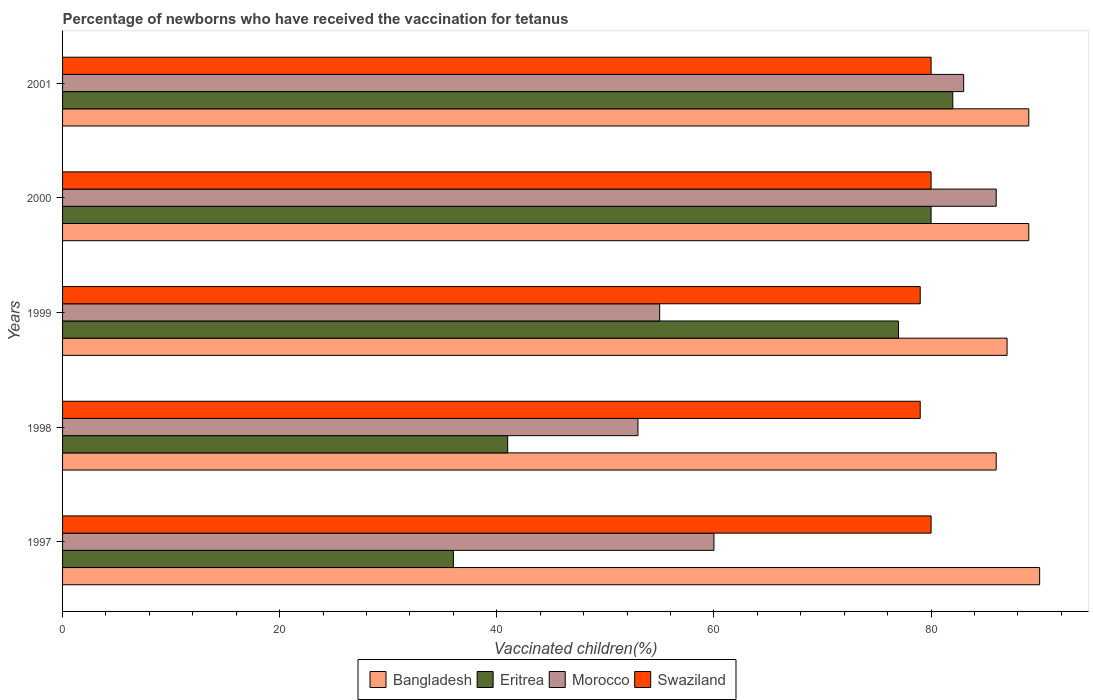Are the number of bars on each tick of the Y-axis equal?
Your answer should be very brief. Yes. How many bars are there on the 2nd tick from the bottom?
Your answer should be very brief. 4. What is the percentage of vaccinated children in Bangladesh in 1999?
Ensure brevity in your answer.  87. In which year was the percentage of vaccinated children in Swaziland maximum?
Your answer should be very brief. 1997. In which year was the percentage of vaccinated children in Eritrea minimum?
Keep it short and to the point. 1997. What is the total percentage of vaccinated children in Bangladesh in the graph?
Your answer should be compact. 441. What is the difference between the percentage of vaccinated children in Eritrea in 1999 and that in 2001?
Give a very brief answer. -5. What is the difference between the percentage of vaccinated children in Eritrea in 1997 and the percentage of vaccinated children in Morocco in 2001?
Give a very brief answer. -47. What is the average percentage of vaccinated children in Swaziland per year?
Your response must be concise. 79.6. What is the ratio of the percentage of vaccinated children in Swaziland in 1997 to that in 1999?
Ensure brevity in your answer.  1.01. In how many years, is the percentage of vaccinated children in Eritrea greater than the average percentage of vaccinated children in Eritrea taken over all years?
Ensure brevity in your answer.  3. Is the sum of the percentage of vaccinated children in Morocco in 1999 and 2000 greater than the maximum percentage of vaccinated children in Bangladesh across all years?
Give a very brief answer. Yes. What does the 3rd bar from the top in 1998 represents?
Keep it short and to the point. Eritrea. What does the 1st bar from the bottom in 2000 represents?
Provide a short and direct response. Bangladesh. Is it the case that in every year, the sum of the percentage of vaccinated children in Eritrea and percentage of vaccinated children in Bangladesh is greater than the percentage of vaccinated children in Swaziland?
Offer a very short reply. Yes. What is the difference between two consecutive major ticks on the X-axis?
Make the answer very short. 20. Does the graph contain any zero values?
Make the answer very short. No. Does the graph contain grids?
Keep it short and to the point. No. What is the title of the graph?
Keep it short and to the point. Percentage of newborns who have received the vaccination for tetanus. Does "Senegal" appear as one of the legend labels in the graph?
Keep it short and to the point. No. What is the label or title of the X-axis?
Give a very brief answer. Vaccinated children(%). What is the Vaccinated children(%) of Eritrea in 1997?
Make the answer very short. 36. What is the Vaccinated children(%) in Swaziland in 1997?
Keep it short and to the point. 80. What is the Vaccinated children(%) in Swaziland in 1998?
Offer a terse response. 79. What is the Vaccinated children(%) of Bangladesh in 1999?
Ensure brevity in your answer.  87. What is the Vaccinated children(%) in Eritrea in 1999?
Provide a short and direct response. 77. What is the Vaccinated children(%) of Morocco in 1999?
Your answer should be very brief. 55. What is the Vaccinated children(%) in Swaziland in 1999?
Make the answer very short. 79. What is the Vaccinated children(%) in Bangladesh in 2000?
Provide a succinct answer. 89. What is the Vaccinated children(%) in Eritrea in 2000?
Your answer should be compact. 80. What is the Vaccinated children(%) in Bangladesh in 2001?
Give a very brief answer. 89. What is the Vaccinated children(%) in Eritrea in 2001?
Your answer should be very brief. 82. What is the Vaccinated children(%) of Morocco in 2001?
Offer a very short reply. 83. What is the Vaccinated children(%) in Swaziland in 2001?
Offer a very short reply. 80. Across all years, what is the maximum Vaccinated children(%) in Bangladesh?
Provide a short and direct response. 90. Across all years, what is the maximum Vaccinated children(%) of Eritrea?
Ensure brevity in your answer.  82. Across all years, what is the maximum Vaccinated children(%) of Morocco?
Provide a succinct answer. 86. Across all years, what is the minimum Vaccinated children(%) of Swaziland?
Make the answer very short. 79. What is the total Vaccinated children(%) of Bangladesh in the graph?
Make the answer very short. 441. What is the total Vaccinated children(%) in Eritrea in the graph?
Your response must be concise. 316. What is the total Vaccinated children(%) in Morocco in the graph?
Your response must be concise. 337. What is the total Vaccinated children(%) in Swaziland in the graph?
Keep it short and to the point. 398. What is the difference between the Vaccinated children(%) of Eritrea in 1997 and that in 1999?
Offer a very short reply. -41. What is the difference between the Vaccinated children(%) of Morocco in 1997 and that in 1999?
Your answer should be very brief. 5. What is the difference between the Vaccinated children(%) of Bangladesh in 1997 and that in 2000?
Give a very brief answer. 1. What is the difference between the Vaccinated children(%) of Eritrea in 1997 and that in 2000?
Your answer should be very brief. -44. What is the difference between the Vaccinated children(%) in Morocco in 1997 and that in 2000?
Ensure brevity in your answer.  -26. What is the difference between the Vaccinated children(%) in Bangladesh in 1997 and that in 2001?
Your answer should be very brief. 1. What is the difference between the Vaccinated children(%) of Eritrea in 1997 and that in 2001?
Offer a terse response. -46. What is the difference between the Vaccinated children(%) of Eritrea in 1998 and that in 1999?
Provide a succinct answer. -36. What is the difference between the Vaccinated children(%) in Morocco in 1998 and that in 1999?
Give a very brief answer. -2. What is the difference between the Vaccinated children(%) in Swaziland in 1998 and that in 1999?
Your response must be concise. 0. What is the difference between the Vaccinated children(%) of Eritrea in 1998 and that in 2000?
Your response must be concise. -39. What is the difference between the Vaccinated children(%) in Morocco in 1998 and that in 2000?
Your answer should be compact. -33. What is the difference between the Vaccinated children(%) in Swaziland in 1998 and that in 2000?
Provide a short and direct response. -1. What is the difference between the Vaccinated children(%) in Eritrea in 1998 and that in 2001?
Keep it short and to the point. -41. What is the difference between the Vaccinated children(%) in Bangladesh in 1999 and that in 2000?
Give a very brief answer. -2. What is the difference between the Vaccinated children(%) of Eritrea in 1999 and that in 2000?
Offer a terse response. -3. What is the difference between the Vaccinated children(%) of Morocco in 1999 and that in 2000?
Ensure brevity in your answer.  -31. What is the difference between the Vaccinated children(%) in Swaziland in 1999 and that in 2000?
Provide a succinct answer. -1. What is the difference between the Vaccinated children(%) in Morocco in 1999 and that in 2001?
Provide a short and direct response. -28. What is the difference between the Vaccinated children(%) in Bangladesh in 2000 and that in 2001?
Keep it short and to the point. 0. What is the difference between the Vaccinated children(%) of Eritrea in 2000 and that in 2001?
Offer a very short reply. -2. What is the difference between the Vaccinated children(%) in Morocco in 2000 and that in 2001?
Ensure brevity in your answer.  3. What is the difference between the Vaccinated children(%) in Swaziland in 2000 and that in 2001?
Your response must be concise. 0. What is the difference between the Vaccinated children(%) of Eritrea in 1997 and the Vaccinated children(%) of Swaziland in 1998?
Ensure brevity in your answer.  -43. What is the difference between the Vaccinated children(%) in Eritrea in 1997 and the Vaccinated children(%) in Swaziland in 1999?
Keep it short and to the point. -43. What is the difference between the Vaccinated children(%) in Bangladesh in 1997 and the Vaccinated children(%) in Eritrea in 2000?
Provide a short and direct response. 10. What is the difference between the Vaccinated children(%) of Bangladesh in 1997 and the Vaccinated children(%) of Morocco in 2000?
Provide a succinct answer. 4. What is the difference between the Vaccinated children(%) in Bangladesh in 1997 and the Vaccinated children(%) in Swaziland in 2000?
Your response must be concise. 10. What is the difference between the Vaccinated children(%) of Eritrea in 1997 and the Vaccinated children(%) of Morocco in 2000?
Provide a short and direct response. -50. What is the difference between the Vaccinated children(%) in Eritrea in 1997 and the Vaccinated children(%) in Swaziland in 2000?
Provide a succinct answer. -44. What is the difference between the Vaccinated children(%) of Morocco in 1997 and the Vaccinated children(%) of Swaziland in 2000?
Offer a very short reply. -20. What is the difference between the Vaccinated children(%) in Bangladesh in 1997 and the Vaccinated children(%) in Eritrea in 2001?
Keep it short and to the point. 8. What is the difference between the Vaccinated children(%) in Eritrea in 1997 and the Vaccinated children(%) in Morocco in 2001?
Keep it short and to the point. -47. What is the difference between the Vaccinated children(%) of Eritrea in 1997 and the Vaccinated children(%) of Swaziland in 2001?
Make the answer very short. -44. What is the difference between the Vaccinated children(%) of Morocco in 1997 and the Vaccinated children(%) of Swaziland in 2001?
Your answer should be very brief. -20. What is the difference between the Vaccinated children(%) of Eritrea in 1998 and the Vaccinated children(%) of Morocco in 1999?
Offer a terse response. -14. What is the difference between the Vaccinated children(%) of Eritrea in 1998 and the Vaccinated children(%) of Swaziland in 1999?
Your response must be concise. -38. What is the difference between the Vaccinated children(%) in Bangladesh in 1998 and the Vaccinated children(%) in Morocco in 2000?
Offer a terse response. 0. What is the difference between the Vaccinated children(%) in Eritrea in 1998 and the Vaccinated children(%) in Morocco in 2000?
Your answer should be compact. -45. What is the difference between the Vaccinated children(%) of Eritrea in 1998 and the Vaccinated children(%) of Swaziland in 2000?
Your answer should be very brief. -39. What is the difference between the Vaccinated children(%) of Bangladesh in 1998 and the Vaccinated children(%) of Eritrea in 2001?
Your response must be concise. 4. What is the difference between the Vaccinated children(%) of Bangladesh in 1998 and the Vaccinated children(%) of Morocco in 2001?
Provide a succinct answer. 3. What is the difference between the Vaccinated children(%) in Eritrea in 1998 and the Vaccinated children(%) in Morocco in 2001?
Provide a short and direct response. -42. What is the difference between the Vaccinated children(%) of Eritrea in 1998 and the Vaccinated children(%) of Swaziland in 2001?
Provide a succinct answer. -39. What is the difference between the Vaccinated children(%) in Morocco in 1998 and the Vaccinated children(%) in Swaziland in 2001?
Offer a very short reply. -27. What is the difference between the Vaccinated children(%) of Bangladesh in 1999 and the Vaccinated children(%) of Eritrea in 2001?
Provide a short and direct response. 5. What is the difference between the Vaccinated children(%) of Bangladesh in 1999 and the Vaccinated children(%) of Morocco in 2001?
Your response must be concise. 4. What is the difference between the Vaccinated children(%) in Bangladesh in 1999 and the Vaccinated children(%) in Swaziland in 2001?
Your response must be concise. 7. What is the difference between the Vaccinated children(%) of Bangladesh in 2000 and the Vaccinated children(%) of Eritrea in 2001?
Keep it short and to the point. 7. What is the difference between the Vaccinated children(%) in Bangladesh in 2000 and the Vaccinated children(%) in Swaziland in 2001?
Provide a short and direct response. 9. What is the difference between the Vaccinated children(%) in Eritrea in 2000 and the Vaccinated children(%) in Morocco in 2001?
Make the answer very short. -3. What is the difference between the Vaccinated children(%) in Eritrea in 2000 and the Vaccinated children(%) in Swaziland in 2001?
Your answer should be very brief. 0. What is the difference between the Vaccinated children(%) in Morocco in 2000 and the Vaccinated children(%) in Swaziland in 2001?
Provide a succinct answer. 6. What is the average Vaccinated children(%) of Bangladesh per year?
Make the answer very short. 88.2. What is the average Vaccinated children(%) in Eritrea per year?
Provide a succinct answer. 63.2. What is the average Vaccinated children(%) of Morocco per year?
Make the answer very short. 67.4. What is the average Vaccinated children(%) of Swaziland per year?
Give a very brief answer. 79.6. In the year 1997, what is the difference between the Vaccinated children(%) in Bangladesh and Vaccinated children(%) in Eritrea?
Provide a succinct answer. 54. In the year 1997, what is the difference between the Vaccinated children(%) of Bangladesh and Vaccinated children(%) of Morocco?
Your answer should be very brief. 30. In the year 1997, what is the difference between the Vaccinated children(%) of Eritrea and Vaccinated children(%) of Morocco?
Keep it short and to the point. -24. In the year 1997, what is the difference between the Vaccinated children(%) in Eritrea and Vaccinated children(%) in Swaziland?
Your answer should be very brief. -44. In the year 1998, what is the difference between the Vaccinated children(%) in Bangladesh and Vaccinated children(%) in Morocco?
Make the answer very short. 33. In the year 1998, what is the difference between the Vaccinated children(%) of Bangladesh and Vaccinated children(%) of Swaziland?
Your response must be concise. 7. In the year 1998, what is the difference between the Vaccinated children(%) in Eritrea and Vaccinated children(%) in Swaziland?
Provide a succinct answer. -38. In the year 1999, what is the difference between the Vaccinated children(%) of Bangladesh and Vaccinated children(%) of Eritrea?
Give a very brief answer. 10. In the year 1999, what is the difference between the Vaccinated children(%) of Bangladesh and Vaccinated children(%) of Morocco?
Offer a terse response. 32. In the year 1999, what is the difference between the Vaccinated children(%) in Bangladesh and Vaccinated children(%) in Swaziland?
Offer a very short reply. 8. In the year 1999, what is the difference between the Vaccinated children(%) of Eritrea and Vaccinated children(%) of Morocco?
Offer a very short reply. 22. In the year 1999, what is the difference between the Vaccinated children(%) of Eritrea and Vaccinated children(%) of Swaziland?
Provide a succinct answer. -2. In the year 2000, what is the difference between the Vaccinated children(%) in Bangladesh and Vaccinated children(%) in Eritrea?
Make the answer very short. 9. In the year 2000, what is the difference between the Vaccinated children(%) in Eritrea and Vaccinated children(%) in Morocco?
Keep it short and to the point. -6. In the year 2000, what is the difference between the Vaccinated children(%) of Morocco and Vaccinated children(%) of Swaziland?
Make the answer very short. 6. In the year 2001, what is the difference between the Vaccinated children(%) of Bangladesh and Vaccinated children(%) of Eritrea?
Keep it short and to the point. 7. In the year 2001, what is the difference between the Vaccinated children(%) of Bangladesh and Vaccinated children(%) of Morocco?
Ensure brevity in your answer.  6. In the year 2001, what is the difference between the Vaccinated children(%) of Bangladesh and Vaccinated children(%) of Swaziland?
Ensure brevity in your answer.  9. What is the ratio of the Vaccinated children(%) of Bangladesh in 1997 to that in 1998?
Keep it short and to the point. 1.05. What is the ratio of the Vaccinated children(%) of Eritrea in 1997 to that in 1998?
Provide a short and direct response. 0.88. What is the ratio of the Vaccinated children(%) in Morocco in 1997 to that in 1998?
Provide a short and direct response. 1.13. What is the ratio of the Vaccinated children(%) in Swaziland in 1997 to that in 1998?
Offer a very short reply. 1.01. What is the ratio of the Vaccinated children(%) of Bangladesh in 1997 to that in 1999?
Your answer should be compact. 1.03. What is the ratio of the Vaccinated children(%) of Eritrea in 1997 to that in 1999?
Offer a terse response. 0.47. What is the ratio of the Vaccinated children(%) in Morocco in 1997 to that in 1999?
Give a very brief answer. 1.09. What is the ratio of the Vaccinated children(%) in Swaziland in 1997 to that in 1999?
Offer a terse response. 1.01. What is the ratio of the Vaccinated children(%) in Bangladesh in 1997 to that in 2000?
Your answer should be compact. 1.01. What is the ratio of the Vaccinated children(%) in Eritrea in 1997 to that in 2000?
Your answer should be compact. 0.45. What is the ratio of the Vaccinated children(%) of Morocco in 1997 to that in 2000?
Your response must be concise. 0.7. What is the ratio of the Vaccinated children(%) of Bangladesh in 1997 to that in 2001?
Offer a very short reply. 1.01. What is the ratio of the Vaccinated children(%) in Eritrea in 1997 to that in 2001?
Your answer should be compact. 0.44. What is the ratio of the Vaccinated children(%) in Morocco in 1997 to that in 2001?
Keep it short and to the point. 0.72. What is the ratio of the Vaccinated children(%) of Eritrea in 1998 to that in 1999?
Your answer should be very brief. 0.53. What is the ratio of the Vaccinated children(%) of Morocco in 1998 to that in 1999?
Ensure brevity in your answer.  0.96. What is the ratio of the Vaccinated children(%) in Swaziland in 1998 to that in 1999?
Your response must be concise. 1. What is the ratio of the Vaccinated children(%) of Bangladesh in 1998 to that in 2000?
Make the answer very short. 0.97. What is the ratio of the Vaccinated children(%) of Eritrea in 1998 to that in 2000?
Provide a short and direct response. 0.51. What is the ratio of the Vaccinated children(%) of Morocco in 1998 to that in 2000?
Offer a very short reply. 0.62. What is the ratio of the Vaccinated children(%) of Swaziland in 1998 to that in 2000?
Provide a short and direct response. 0.99. What is the ratio of the Vaccinated children(%) in Bangladesh in 1998 to that in 2001?
Offer a terse response. 0.97. What is the ratio of the Vaccinated children(%) in Morocco in 1998 to that in 2001?
Your answer should be compact. 0.64. What is the ratio of the Vaccinated children(%) in Swaziland in 1998 to that in 2001?
Ensure brevity in your answer.  0.99. What is the ratio of the Vaccinated children(%) of Bangladesh in 1999 to that in 2000?
Keep it short and to the point. 0.98. What is the ratio of the Vaccinated children(%) in Eritrea in 1999 to that in 2000?
Provide a succinct answer. 0.96. What is the ratio of the Vaccinated children(%) of Morocco in 1999 to that in 2000?
Ensure brevity in your answer.  0.64. What is the ratio of the Vaccinated children(%) in Swaziland in 1999 to that in 2000?
Offer a terse response. 0.99. What is the ratio of the Vaccinated children(%) in Bangladesh in 1999 to that in 2001?
Offer a very short reply. 0.98. What is the ratio of the Vaccinated children(%) of Eritrea in 1999 to that in 2001?
Provide a succinct answer. 0.94. What is the ratio of the Vaccinated children(%) of Morocco in 1999 to that in 2001?
Ensure brevity in your answer.  0.66. What is the ratio of the Vaccinated children(%) of Swaziland in 1999 to that in 2001?
Offer a terse response. 0.99. What is the ratio of the Vaccinated children(%) in Eritrea in 2000 to that in 2001?
Ensure brevity in your answer.  0.98. What is the ratio of the Vaccinated children(%) in Morocco in 2000 to that in 2001?
Provide a succinct answer. 1.04. What is the ratio of the Vaccinated children(%) of Swaziland in 2000 to that in 2001?
Ensure brevity in your answer.  1. What is the difference between the highest and the second highest Vaccinated children(%) of Bangladesh?
Your answer should be very brief. 1. What is the difference between the highest and the second highest Vaccinated children(%) of Eritrea?
Your response must be concise. 2. What is the difference between the highest and the second highest Vaccinated children(%) in Swaziland?
Your answer should be compact. 0. What is the difference between the highest and the lowest Vaccinated children(%) of Swaziland?
Ensure brevity in your answer.  1. 